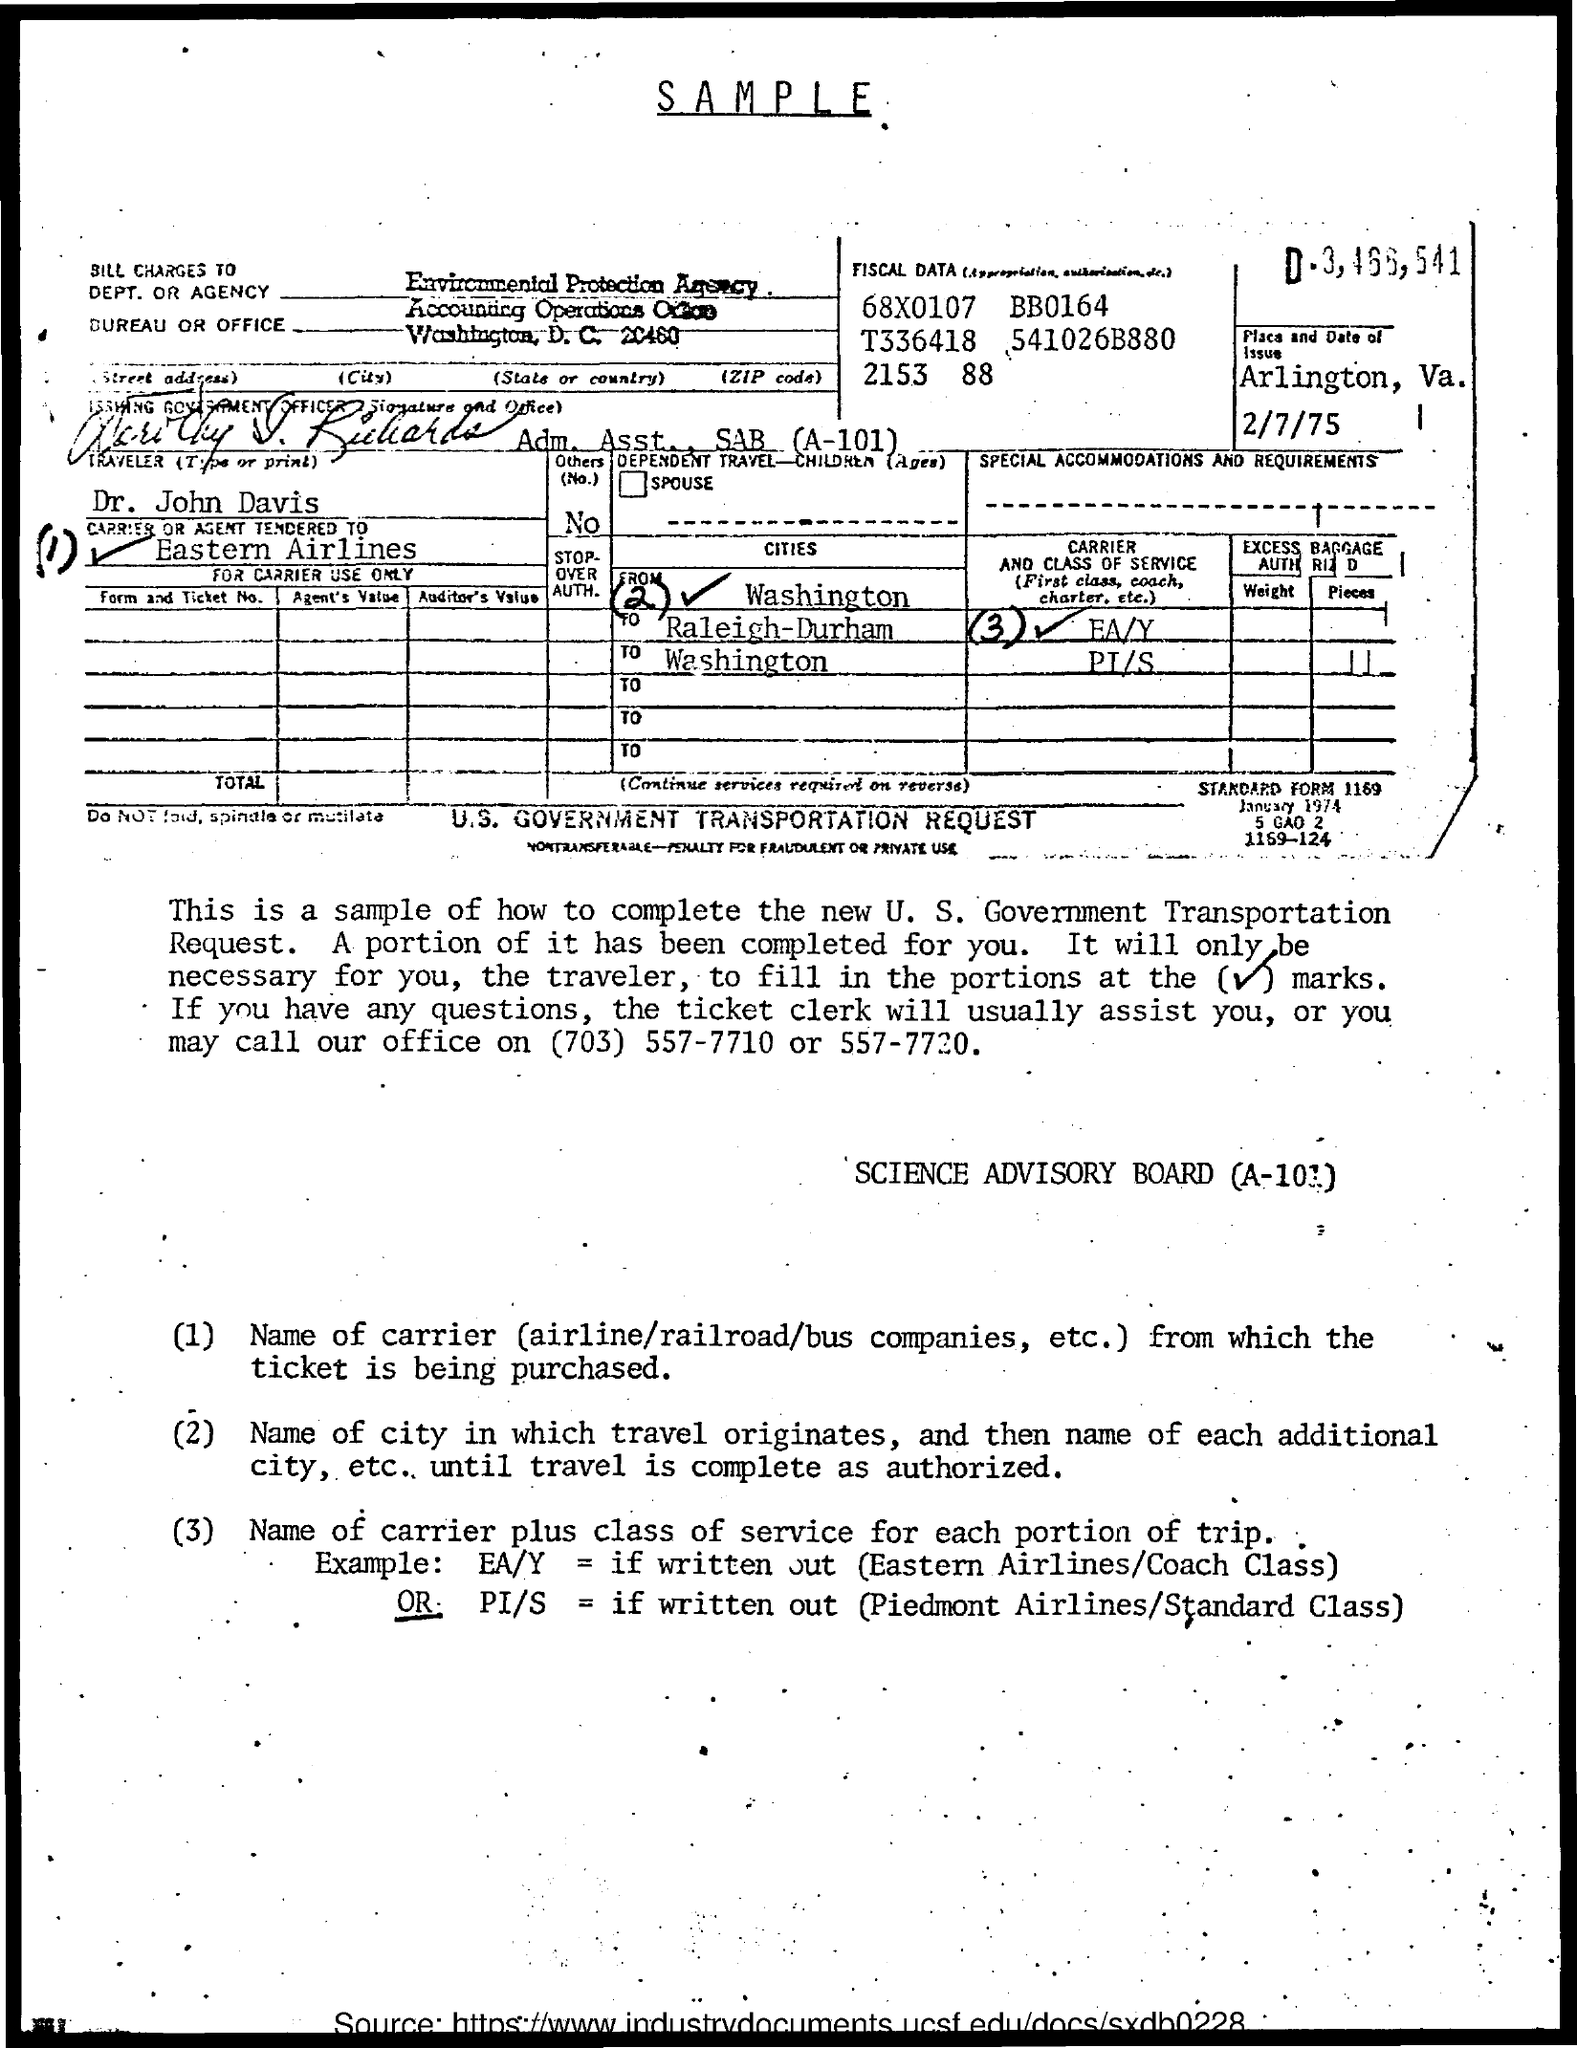Indicate a few pertinent items in this graphic. The bill is charged to the Environmental Protection Agency Accounting Operations Office. 